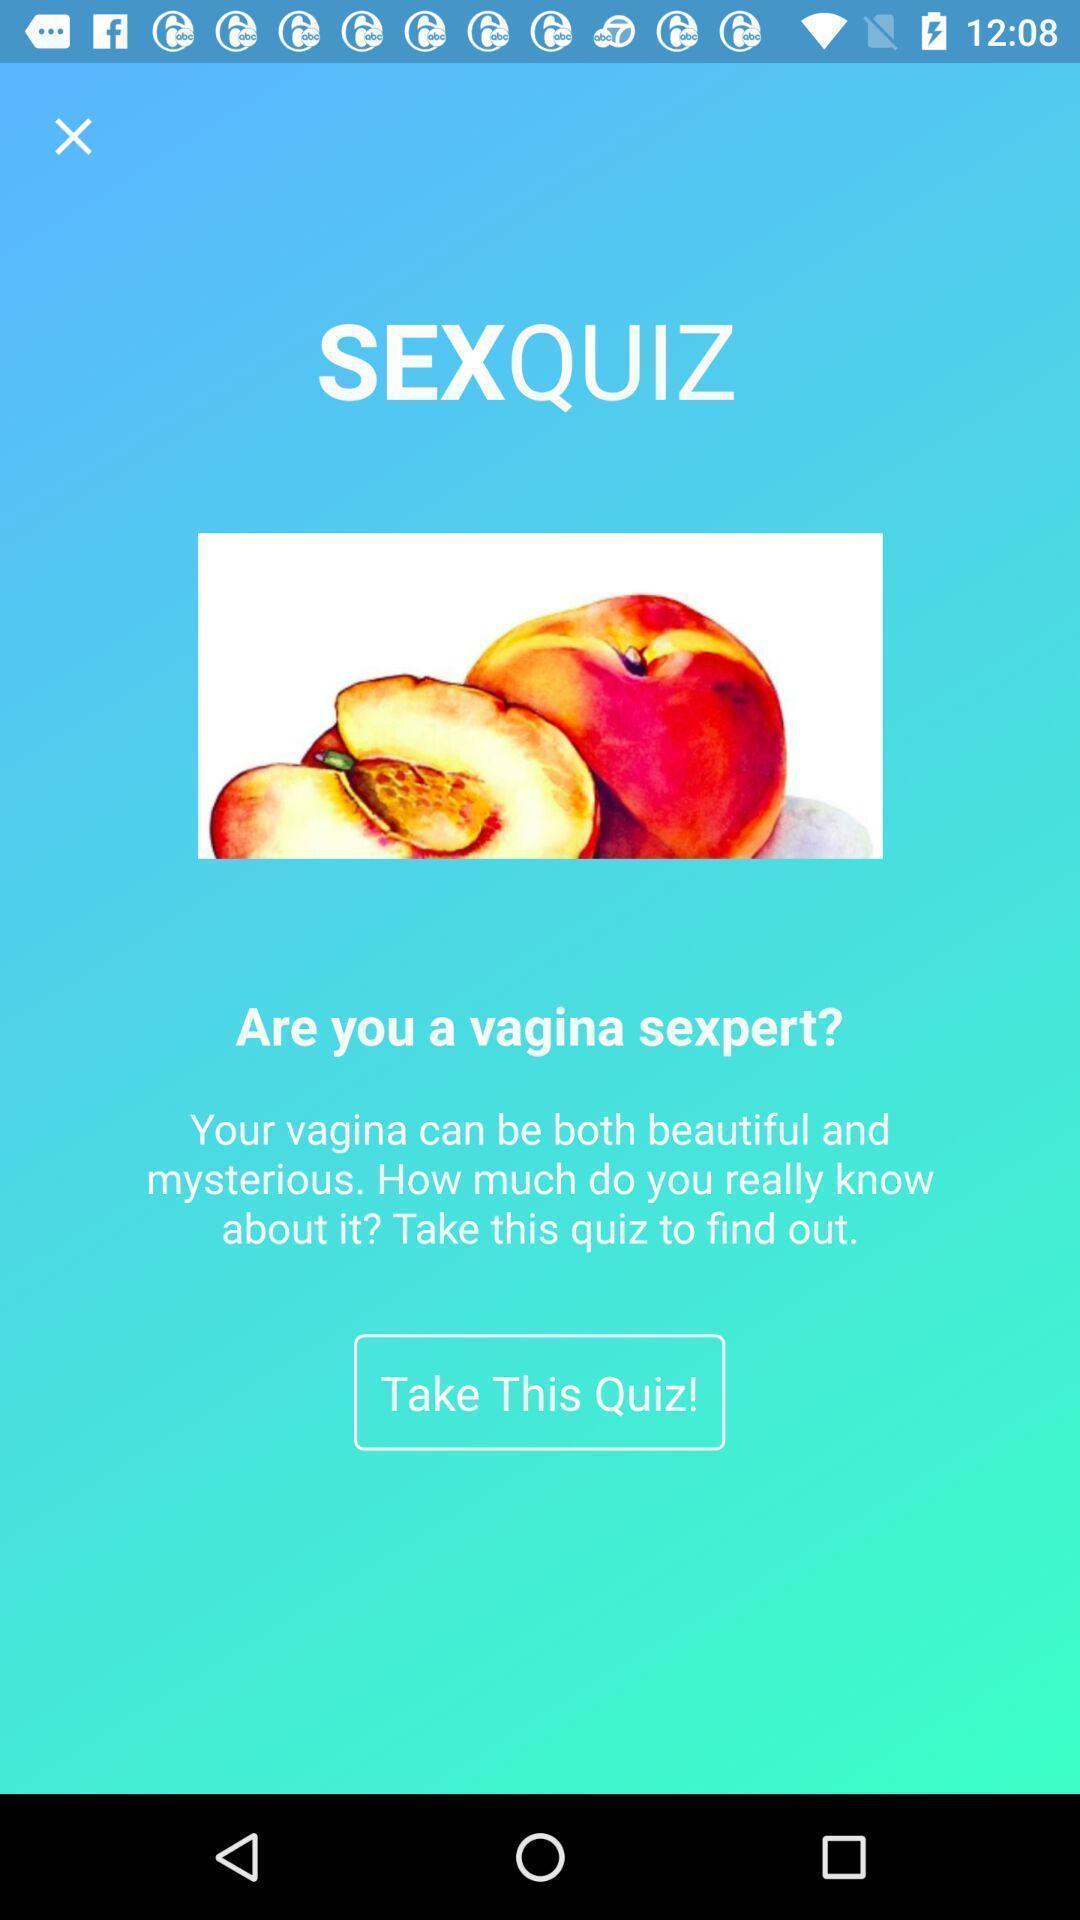Describe the content in this image. Welcome page with quiz option in health application. 